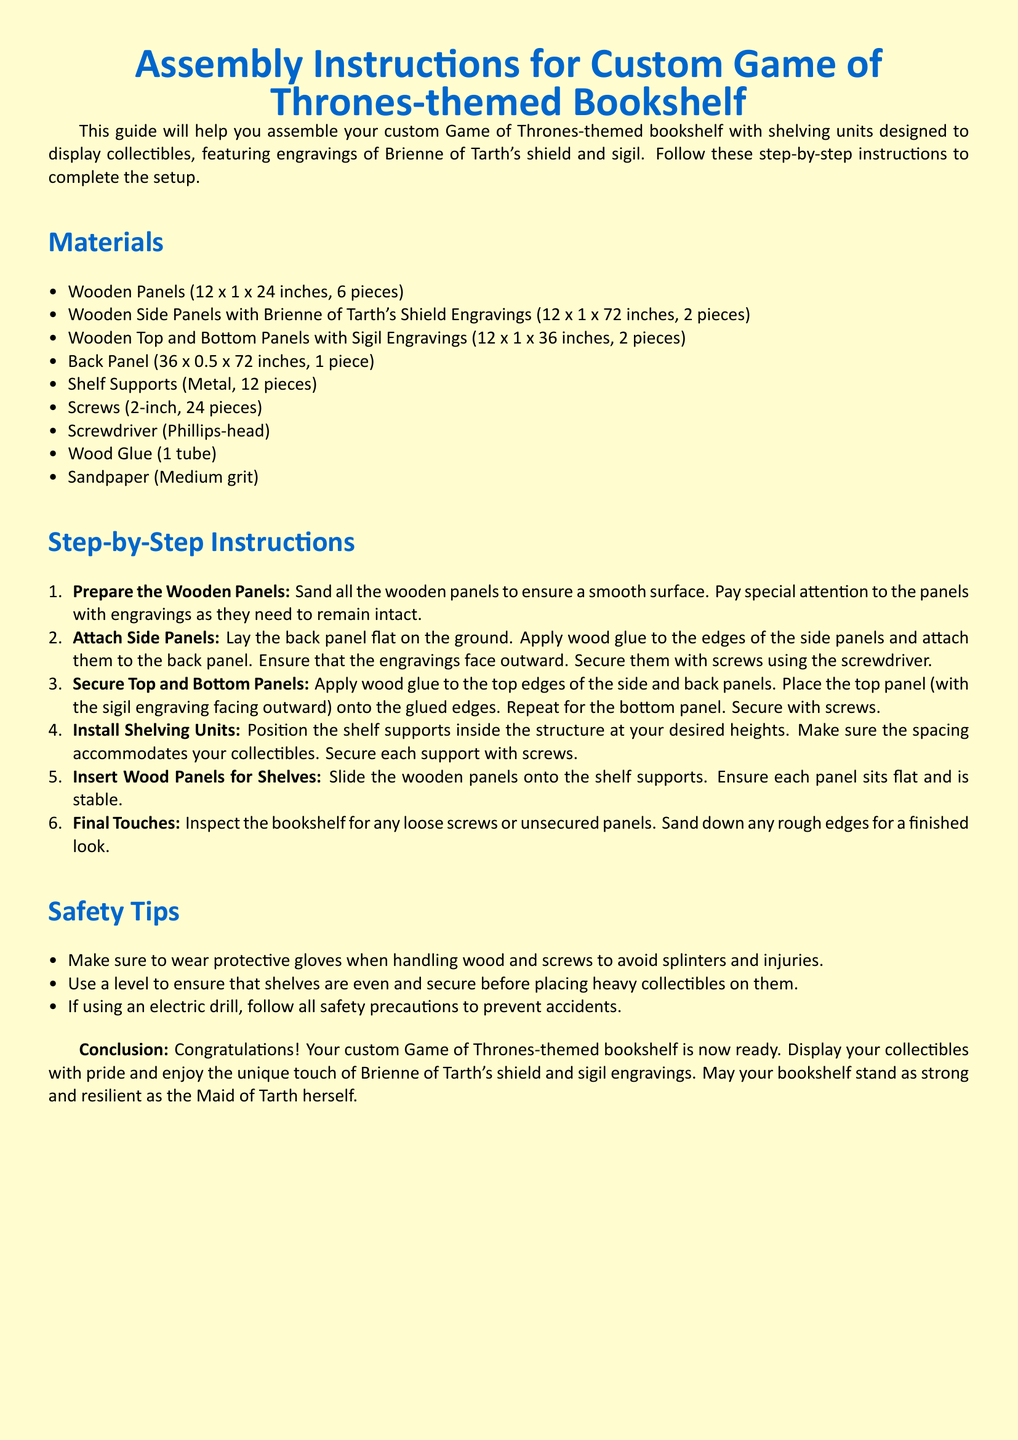What are the dimensions of the side panels? The dimensions of the wooden side panels are specified in the materials section of the document as 12 x 1 x 72 inches.
Answer: 12 x 1 x 72 inches How many shelf supports are included? The number of shelf supports is listed in the materials section, which states there are 12 pieces.
Answer: 12 pieces What should be applied to attach the side panels? The instructions indicate that wood glue should be applied to the edges of the side panels to attach them.
Answer: Wood glue What is the purpose of sanding the wooden panels? Sanding the panels is outlined in the first step of the instructions to ensure a smooth surface, especially for engraved panels.
Answer: Smooth surface What engraving is featured on the side panels? The document mentions the side panels have Brienne of Tarth's shield engravings on them.
Answer: Brienne of Tarth's shield How many screws are required in total for the assembly? The total number of screws required is specified in the materials section as 24 pieces.
Answer: 24 pieces What safety equipment is advised while assembling? The safety tips suggest wearing protective gloves when handling wood and screws to avoid injuries.
Answer: Protective gloves What should be used to ensure the shelves are even? The safety tips recommend using a level to make sure that the shelves are even before placing collectibles on them.
Answer: Level 